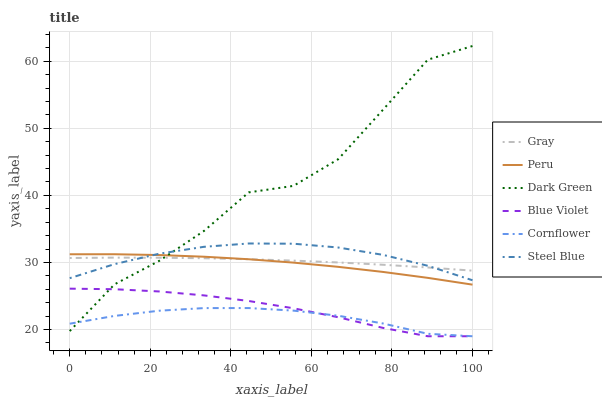Does Cornflower have the minimum area under the curve?
Answer yes or no. Yes. Does Dark Green have the maximum area under the curve?
Answer yes or no. Yes. Does Steel Blue have the minimum area under the curve?
Answer yes or no. No. Does Steel Blue have the maximum area under the curve?
Answer yes or no. No. Is Gray the smoothest?
Answer yes or no. Yes. Is Dark Green the roughest?
Answer yes or no. Yes. Is Cornflower the smoothest?
Answer yes or no. No. Is Cornflower the roughest?
Answer yes or no. No. Does Steel Blue have the lowest value?
Answer yes or no. No. Does Dark Green have the highest value?
Answer yes or no. Yes. Does Steel Blue have the highest value?
Answer yes or no. No. Is Cornflower less than Gray?
Answer yes or no. Yes. Is Peru greater than Blue Violet?
Answer yes or no. Yes. Does Dark Green intersect Steel Blue?
Answer yes or no. Yes. Is Dark Green less than Steel Blue?
Answer yes or no. No. Is Dark Green greater than Steel Blue?
Answer yes or no. No. Does Cornflower intersect Gray?
Answer yes or no. No. 